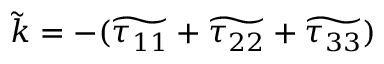<formula> <loc_0><loc_0><loc_500><loc_500>\widetilde { k } = - ( \widetilde { \tau _ { 1 1 } } + \widetilde { \tau _ { 2 2 } } + \widetilde { \tau _ { 3 3 } } )</formula> 